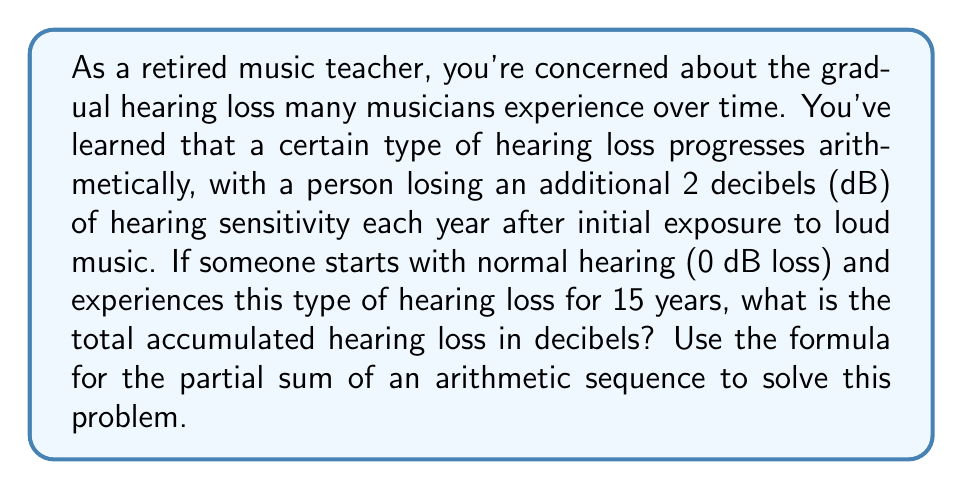Teach me how to tackle this problem. Let's approach this step-by-step using the arithmetic sequence formula:

1) First, recall the formula for the partial sum of an arithmetic sequence:
   $$ S_n = \frac{n}{2}(a_1 + a_n) $$
   where $S_n$ is the sum of the first $n$ terms, $a_1$ is the first term, and $a_n$ is the last term.

2) In this problem:
   - $n = 15$ (15 years)
   - $a_1 = 2$ (2 dB loss in the first year)
   - The common difference $d = 2$ (additional 2 dB loss each year)

3) To find $a_n$, use the arithmetic sequence formula:
   $$ a_n = a_1 + (n-1)d $$
   $$ a_{15} = 2 + (15-1)(2) = 2 + 28 = 30 $$

4) Now we can plug these values into the partial sum formula:
   $$ S_{15} = \frac{15}{2}(2 + 30) $$

5) Simplify:
   $$ S_{15} = \frac{15}{2}(32) = 15(16) = 240 $$

Therefore, the total accumulated hearing loss over 15 years is 240 dB.
Answer: $240$ dB 